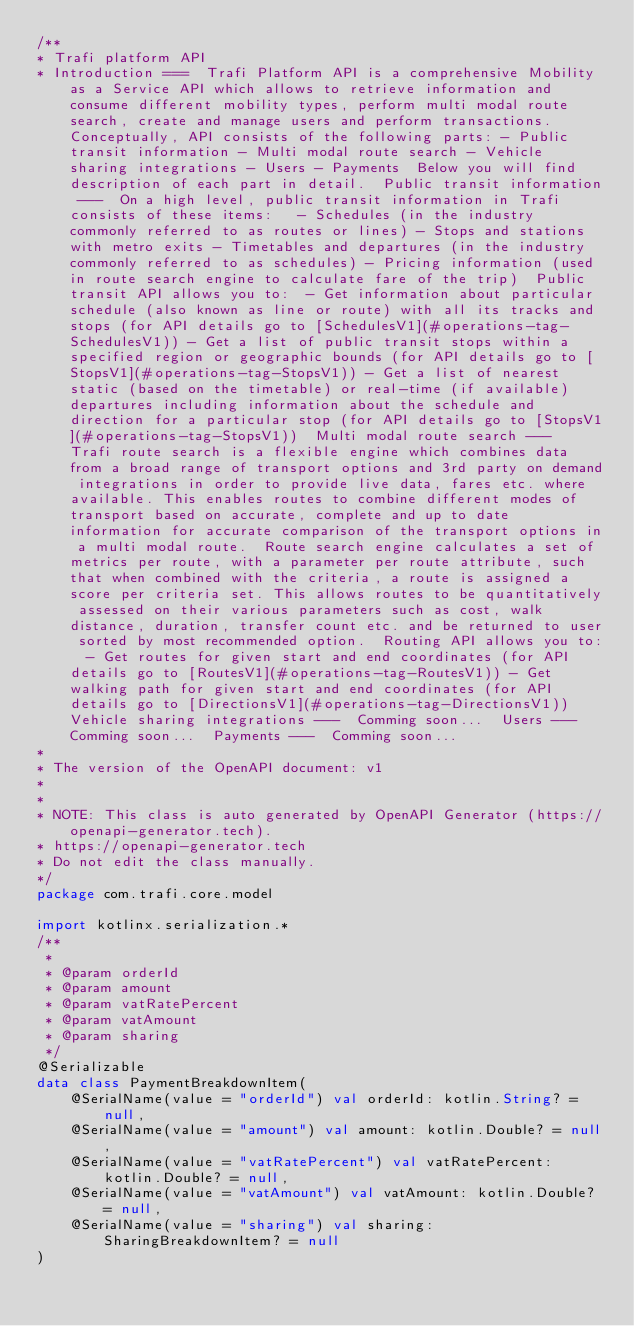Convert code to text. <code><loc_0><loc_0><loc_500><loc_500><_Kotlin_>/**
* Trafi platform API
* Introduction ===  Trafi Platform API is a comprehensive Mobility as a Service API which allows to retrieve information and consume different mobility types, perform multi modal route search, create and manage users and perform transactions.  Conceptually, API consists of the following parts: - Public transit information - Multi modal route search - Vehicle sharing integrations - Users - Payments  Below you will find description of each part in detail.  Public transit information ---  On a high level, public transit information in Trafi consists of these items:   - Schedules (in the industry commonly referred to as routes or lines) - Stops and stations with metro exits - Timetables and departures (in the industry commonly referred to as schedules) - Pricing information (used in route search engine to calculate fare of the trip)  Public transit API allows you to:  - Get information about particular schedule (also known as line or route) with all its tracks and stops (for API details go to [SchedulesV1](#operations-tag-SchedulesV1)) - Get a list of public transit stops within a specified region or geographic bounds (for API details go to [StopsV1](#operations-tag-StopsV1)) - Get a list of nearest static (based on the timetable) or real-time (if available) departures including information about the schedule and direction for a particular stop (for API details go to [StopsV1](#operations-tag-StopsV1))  Multi modal route search ---  Trafi route search is a flexible engine which combines data from a broad range of transport options and 3rd party on demand integrations in order to provide live data, fares etc. where available. This enables routes to combine different modes of transport based on accurate, complete and up to date information for accurate comparison of the transport options in a multi modal route.  Route search engine calculates a set of metrics per route, with a parameter per route attribute, such that when combined with the criteria, a route is assigned a score per criteria set. This allows routes to be quantitatively assessed on their various parameters such as cost, walk distance, duration, transfer count etc. and be returned to user sorted by most recommended option.  Routing API allows you to:  - Get routes for given start and end coordinates (for API details go to [RoutesV1](#operations-tag-RoutesV1)) - Get walking path for given start and end coordinates (for API details go to [DirectionsV1](#operations-tag-DirectionsV1))  Vehicle sharing integrations ---  Comming soon...  Users ---  Comming soon...  Payments ---  Comming soon...
*
* The version of the OpenAPI document: v1
*
*
* NOTE: This class is auto generated by OpenAPI Generator (https://openapi-generator.tech).
* https://openapi-generator.tech
* Do not edit the class manually.
*/
package com.trafi.core.model

import kotlinx.serialization.*
/**
 *
 * @param orderId
 * @param amount
 * @param vatRatePercent
 * @param vatAmount
 * @param sharing
 */
@Serializable
data class PaymentBreakdownItem(
    @SerialName(value = "orderId") val orderId: kotlin.String? = null,
    @SerialName(value = "amount") val amount: kotlin.Double? = null,
    @SerialName(value = "vatRatePercent") val vatRatePercent: kotlin.Double? = null,
    @SerialName(value = "vatAmount") val vatAmount: kotlin.Double? = null,
    @SerialName(value = "sharing") val sharing: SharingBreakdownItem? = null
)
</code> 